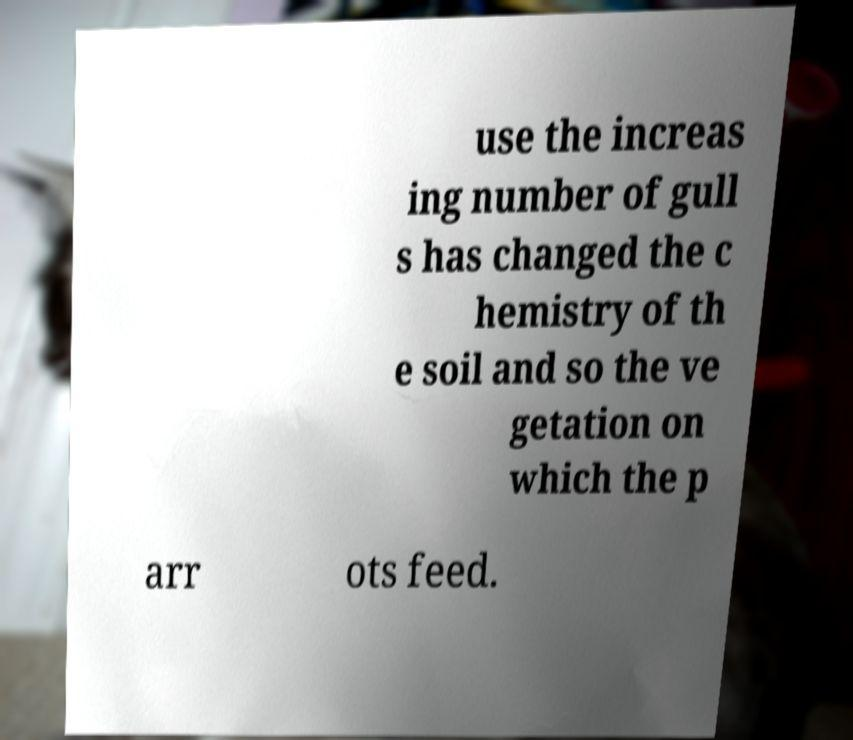There's text embedded in this image that I need extracted. Can you transcribe it verbatim? use the increas ing number of gull s has changed the c hemistry of th e soil and so the ve getation on which the p arr ots feed. 